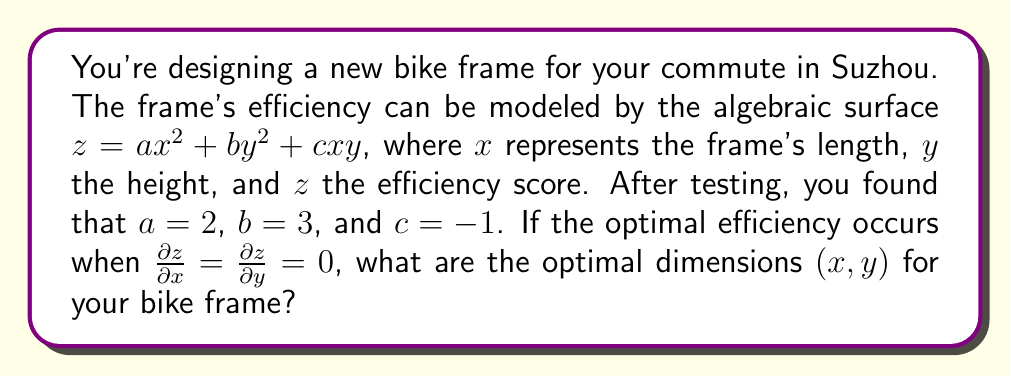Could you help me with this problem? To find the optimal dimensions, we need to follow these steps:

1) First, let's write out the equation for the efficiency surface:
   $$z = 2x^2 + 3y^2 - xy$$

2) To find the optimal point, we need to calculate the partial derivatives and set them to zero:

   $$\frac{\partial z}{\partial x} = 4x - y = 0$$
   $$\frac{\partial z}{\partial y} = 6y - x = 0$$

3) Now we have a system of two equations:
   $$4x - y = 0$$
   $$-x + 6y = 0$$

4) From the first equation:
   $$y = 4x$$

5) Substitute this into the second equation:
   $$-x + 6(4x) = 0$$
   $$-x + 24x = 0$$
   $$23x = 0$$
   $$x = 0$$

6) If $x = 0$, then from step 4, we can see that $y = 0$ as well.

7) Therefore, the optimal point is at $(0, 0)$. However, this represents a bike with no length or height, which is not practical.

8) In reality, this means that the most efficient bike frame would be as small as practically possible while still being rideable.
Answer: $(0, 0)$ 